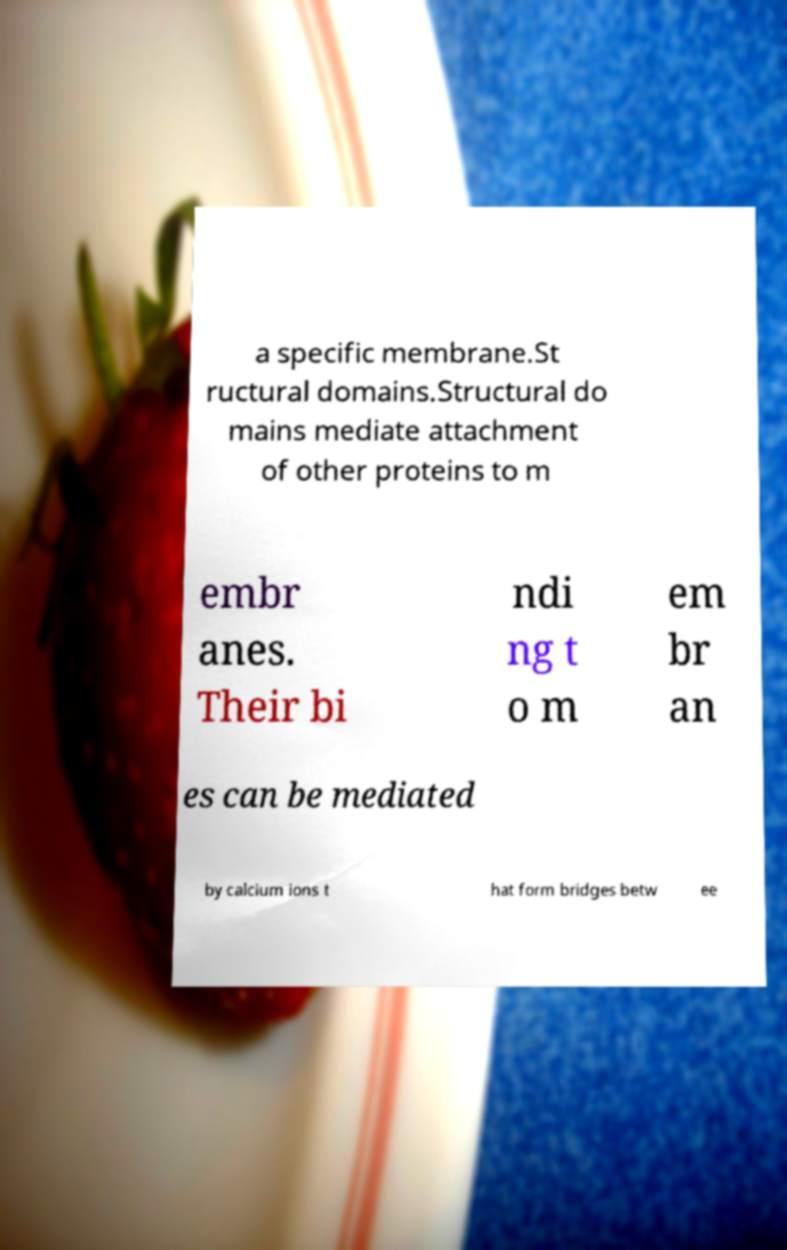Please identify and transcribe the text found in this image. a specific membrane.St ructural domains.Structural do mains mediate attachment of other proteins to m embr anes. Their bi ndi ng t o m em br an es can be mediated by calcium ions t hat form bridges betw ee 